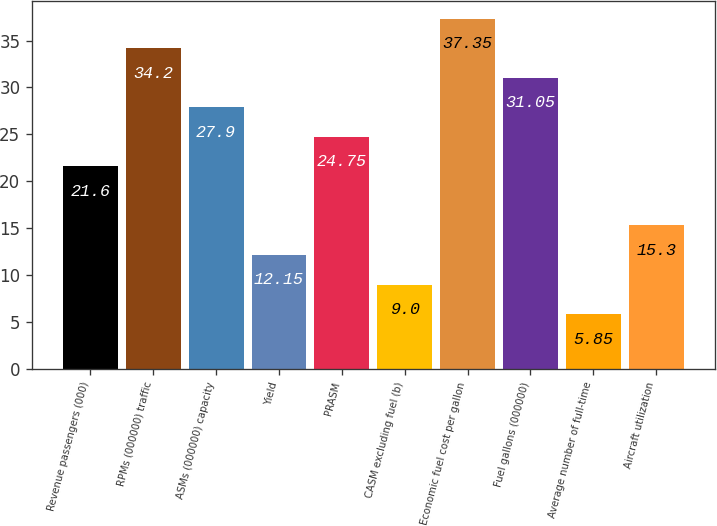Convert chart. <chart><loc_0><loc_0><loc_500><loc_500><bar_chart><fcel>Revenue passengers (000)<fcel>RPMs (000000) traffic<fcel>ASMs (000000) capacity<fcel>Yield<fcel>PRASM<fcel>CASM excluding fuel (b)<fcel>Economic fuel cost per gallon<fcel>Fuel gallons (000000)<fcel>Average number of full-time<fcel>Aircraft utilization<nl><fcel>21.6<fcel>34.2<fcel>27.9<fcel>12.15<fcel>24.75<fcel>9<fcel>37.35<fcel>31.05<fcel>5.85<fcel>15.3<nl></chart> 